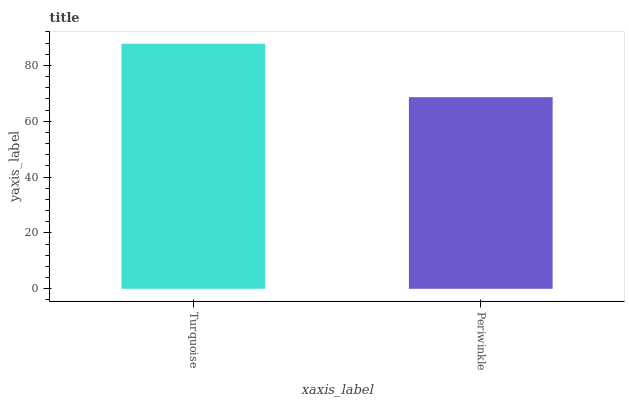Is Periwinkle the minimum?
Answer yes or no. Yes. Is Turquoise the maximum?
Answer yes or no. Yes. Is Periwinkle the maximum?
Answer yes or no. No. Is Turquoise greater than Periwinkle?
Answer yes or no. Yes. Is Periwinkle less than Turquoise?
Answer yes or no. Yes. Is Periwinkle greater than Turquoise?
Answer yes or no. No. Is Turquoise less than Periwinkle?
Answer yes or no. No. Is Turquoise the high median?
Answer yes or no. Yes. Is Periwinkle the low median?
Answer yes or no. Yes. Is Periwinkle the high median?
Answer yes or no. No. Is Turquoise the low median?
Answer yes or no. No. 